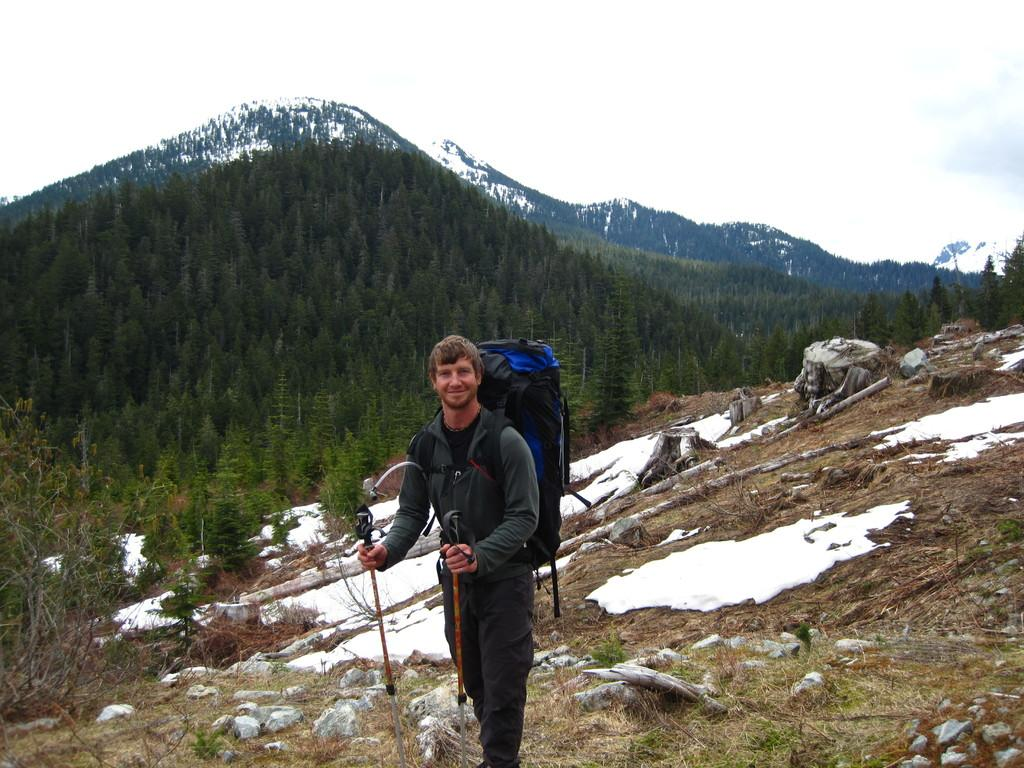Who is present in the image? There is a man in the image. What is the man doing in the image? The man is standing on the ground. What is the man carrying on his back? The man is wearing a backpack. What is the man holding in his hands? The man is holding walking sticks in his hands. What can be seen in the background of the image? There are plants, trees, mountains, and the sky visible in the background of the image. What type of plant is the man using to sew a new addition to his backpack? There is no plant present in the image, and the man is not sewing anything. 